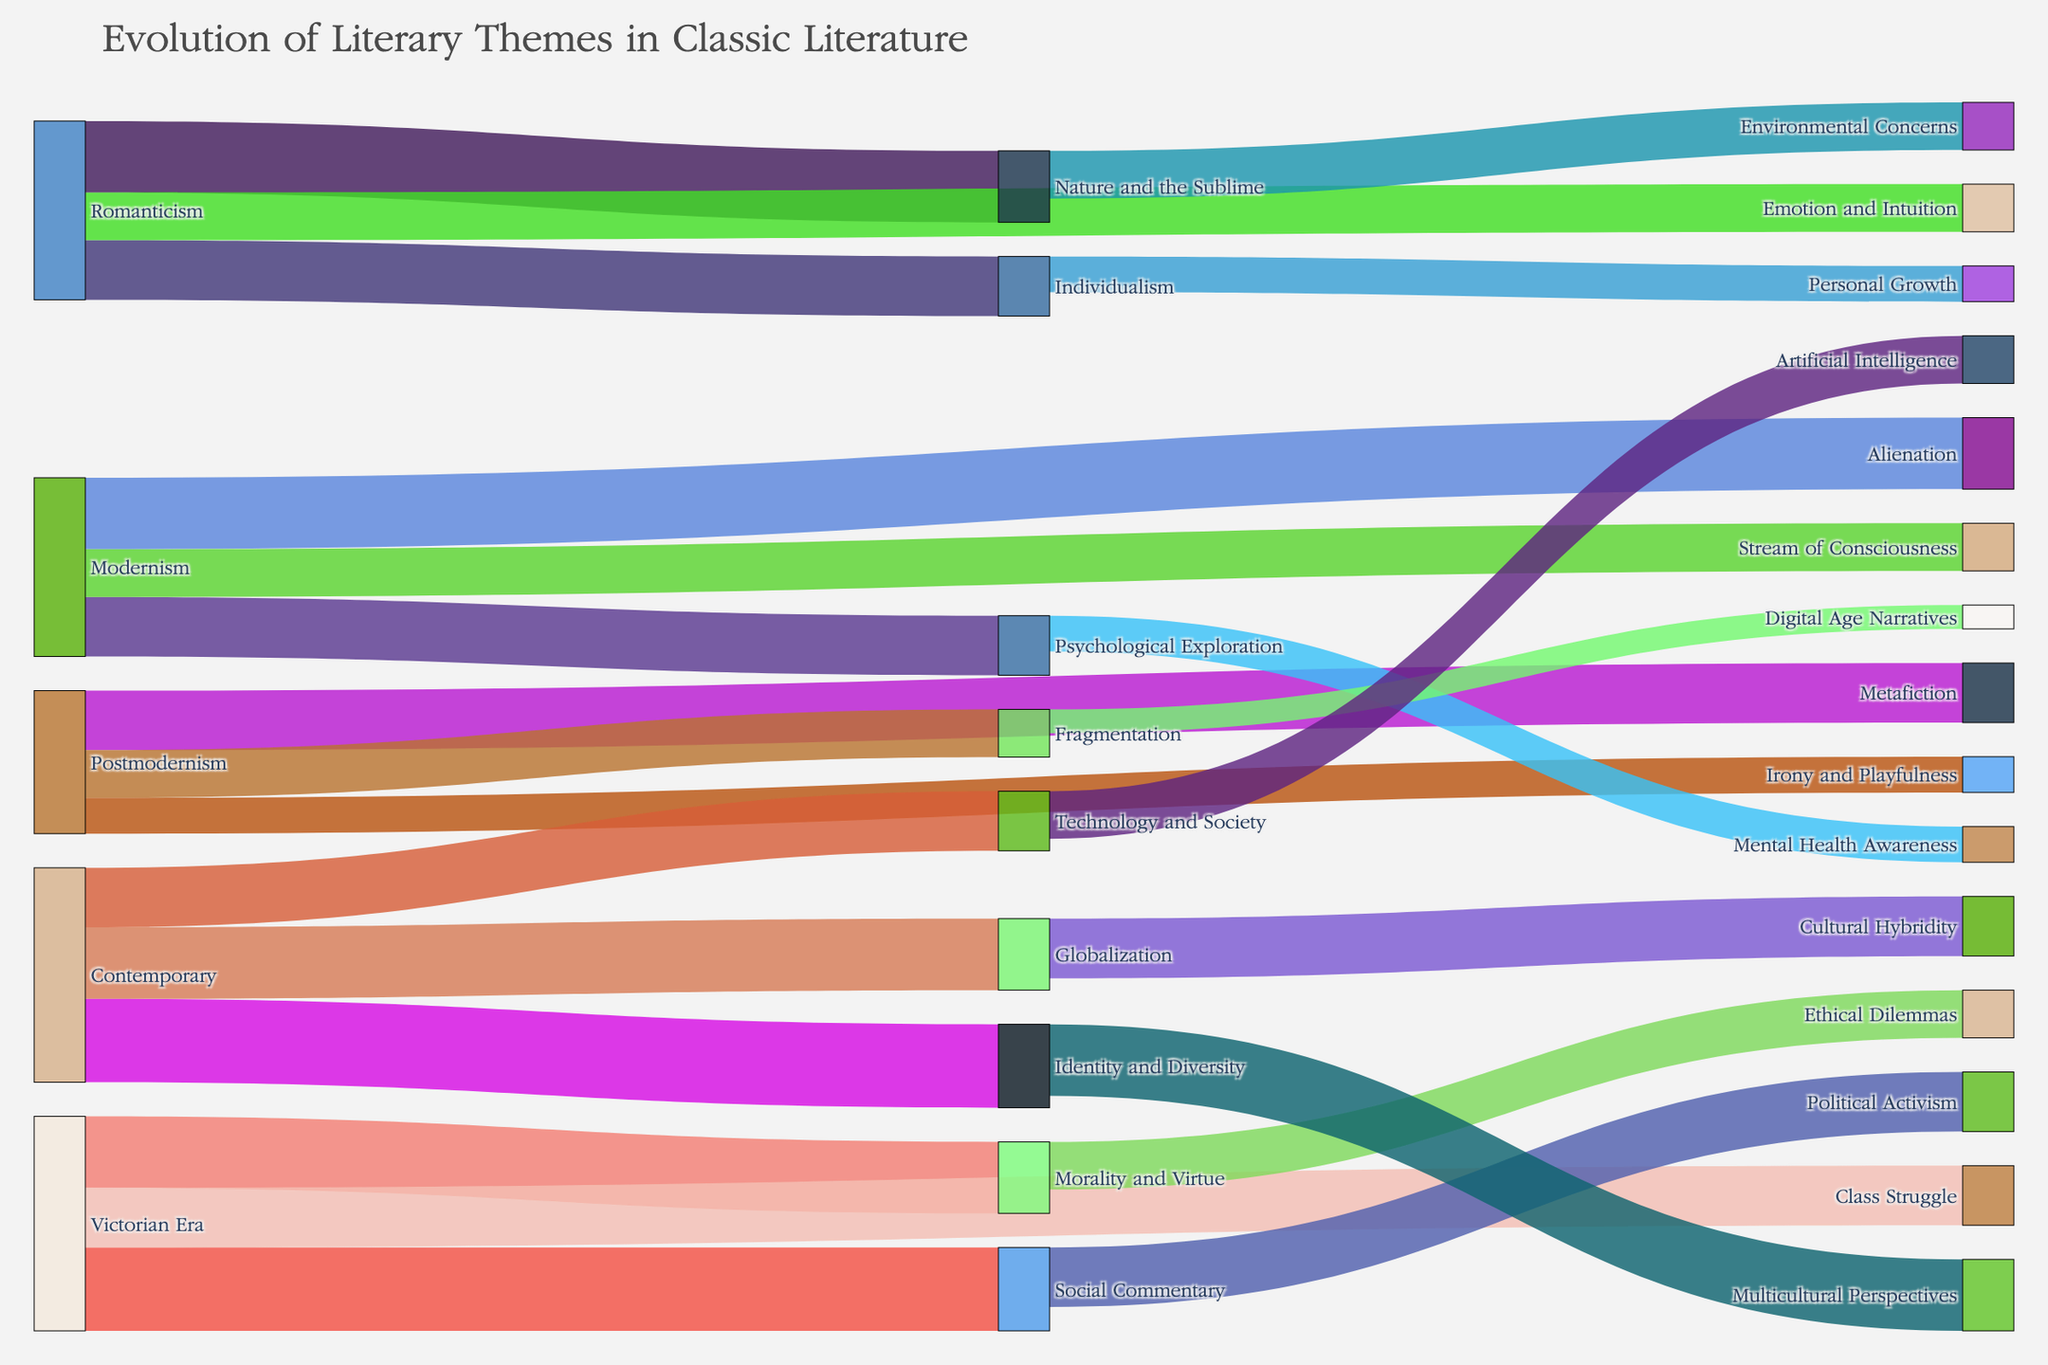Which literary theme from the Romanticism era evolved into environmental concerns? Observe the flow originating from Romanticism and track where it leads among the various themes. One of the themes, "Nature and the Sublime," continues as "Environmental Concerns."
Answer: Nature and the Sublime What is the most prevalent theme in Contemporary literature? Examine the height (value) of the blocks corresponding to Contemporary themes. The biggest block indicates the most prevalent theme. "Identity and Diversity" has the largest block.
Answer: Identity and Diversity How does the value of Social Commentary in the Victorian Era compare to Political Activism? Locate the flow from Victorian Era to Social Commentary and another flow from Social Commentary to Political Activism. Both are linked through their values, with "Social Commentary" at 35 units and "Political Activism" at 25 units. The Victorian Era has a higher value for Social Commentary.
Answer: Social Commentary is higher Which themes from Modernism delve into understanding the psyche? Follow the link from Modernism to its subsequent themes. "Psychological Exploration" specifically deals with understanding the human mind and psyche.
Answer: Psychological Exploration How many themes emerged from Romanticism? Count all the direct links originating from the Romanticism node to its subsequent themes. There are three themes linked: "Nature and the Sublime," "Individualism," and "Emotion and Intuition."
Answer: Three themes What are the subsequent themes for Technology and Society? Track flows originating from the node "Technology and Society" to see where they lead. There's only one, leading to "Artificial Intelligence."
Answer: Artificial Intelligence What is the cumulative value for all the themes originating from Victorian Era? Sum up the values of all the outgoing flows from the Victorian Era node. The values are 35 (Social Commentary), 30 (Morality and Virtue), and 25 (Class Struggle), totaling 90.
Answer: 90 Which thematic flow has the smallest value? Identify the smallest flow value by comparing all the links. The flow from "Fragmentation" to "Digital Age Narratives" has the smallest value with only 10 units.
Answer: Fragmentation to Digital Age Narratives What modern literary theme connects Cultural Hybridity and Political Activism? Trace the flows leading from "Globalization" and "Social Commentary" to find any common theme. "Cultural Hybridity" and "Political Activism" don't directly connect through any one theme.
Answer: No direct common theme 